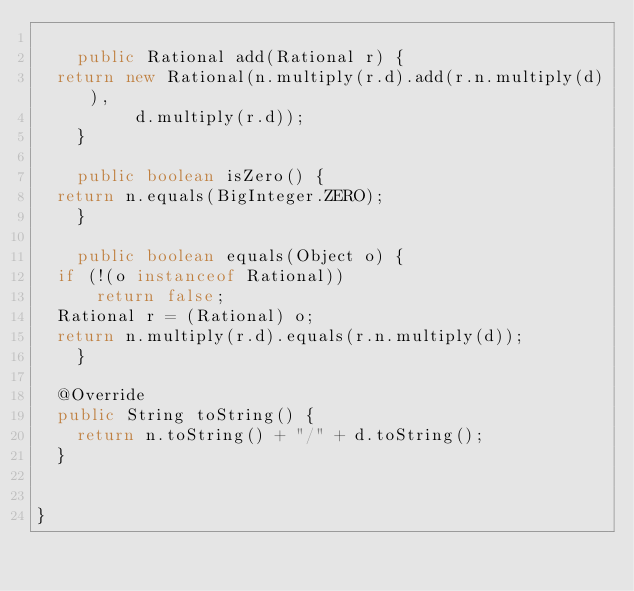<code> <loc_0><loc_0><loc_500><loc_500><_Java_>
    public Rational add(Rational r) {
	return new Rational(n.multiply(r.d).add(r.n.multiply(d)),
			    d.multiply(r.d));
    }

    public boolean isZero() {
	return n.equals(BigInteger.ZERO);
    }

    public boolean equals(Object o) {
	if (!(o instanceof Rational))
	    return false;
	Rational r = (Rational) o;
	return n.multiply(r.d).equals(r.n.multiply(d));
    }

	@Override
	public String toString() {
		return n.toString() + "/" + d.toString();
	}
    
    
}
</code> 